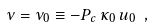Convert formula to latex. <formula><loc_0><loc_0><loc_500><loc_500>\nu = \nu _ { 0 } \equiv - P _ { c } \, \kappa _ { 0 } \, u _ { 0 } \ ,</formula> 